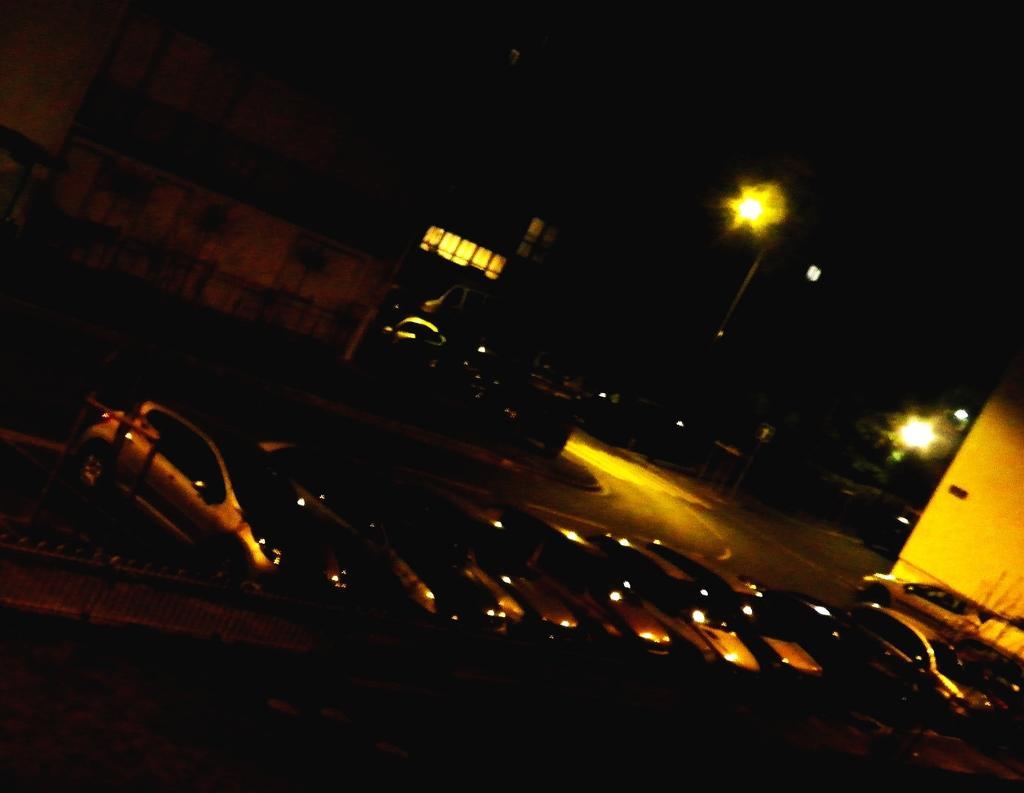Could you give a brief overview of what you see in this image? The image is dark. We can see vehicles on the road, buildings, light poles, lights and other objects. 